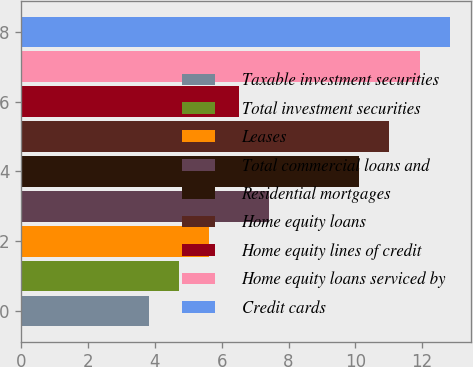Convert chart. <chart><loc_0><loc_0><loc_500><loc_500><bar_chart><fcel>Taxable investment securities<fcel>Total investment securities<fcel>Leases<fcel>Total commercial loans and<fcel>Residential mortgages<fcel>Home equity loans<fcel>Home equity lines of credit<fcel>Home equity loans serviced by<fcel>Credit cards<nl><fcel>3.82<fcel>4.72<fcel>5.62<fcel>7.42<fcel>10.12<fcel>11.02<fcel>6.52<fcel>11.92<fcel>12.82<nl></chart> 